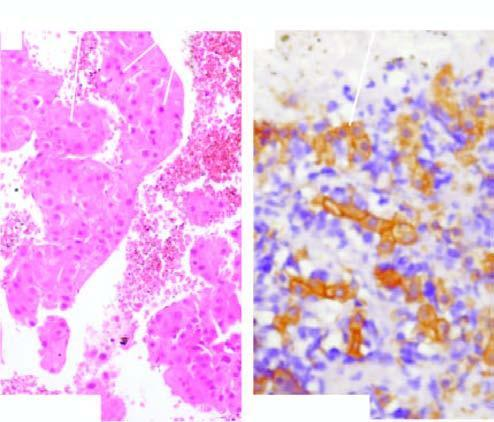what is stained with cytokeratin for epithelial cells?
Answer the question using a single word or phrase. Same cellblock 